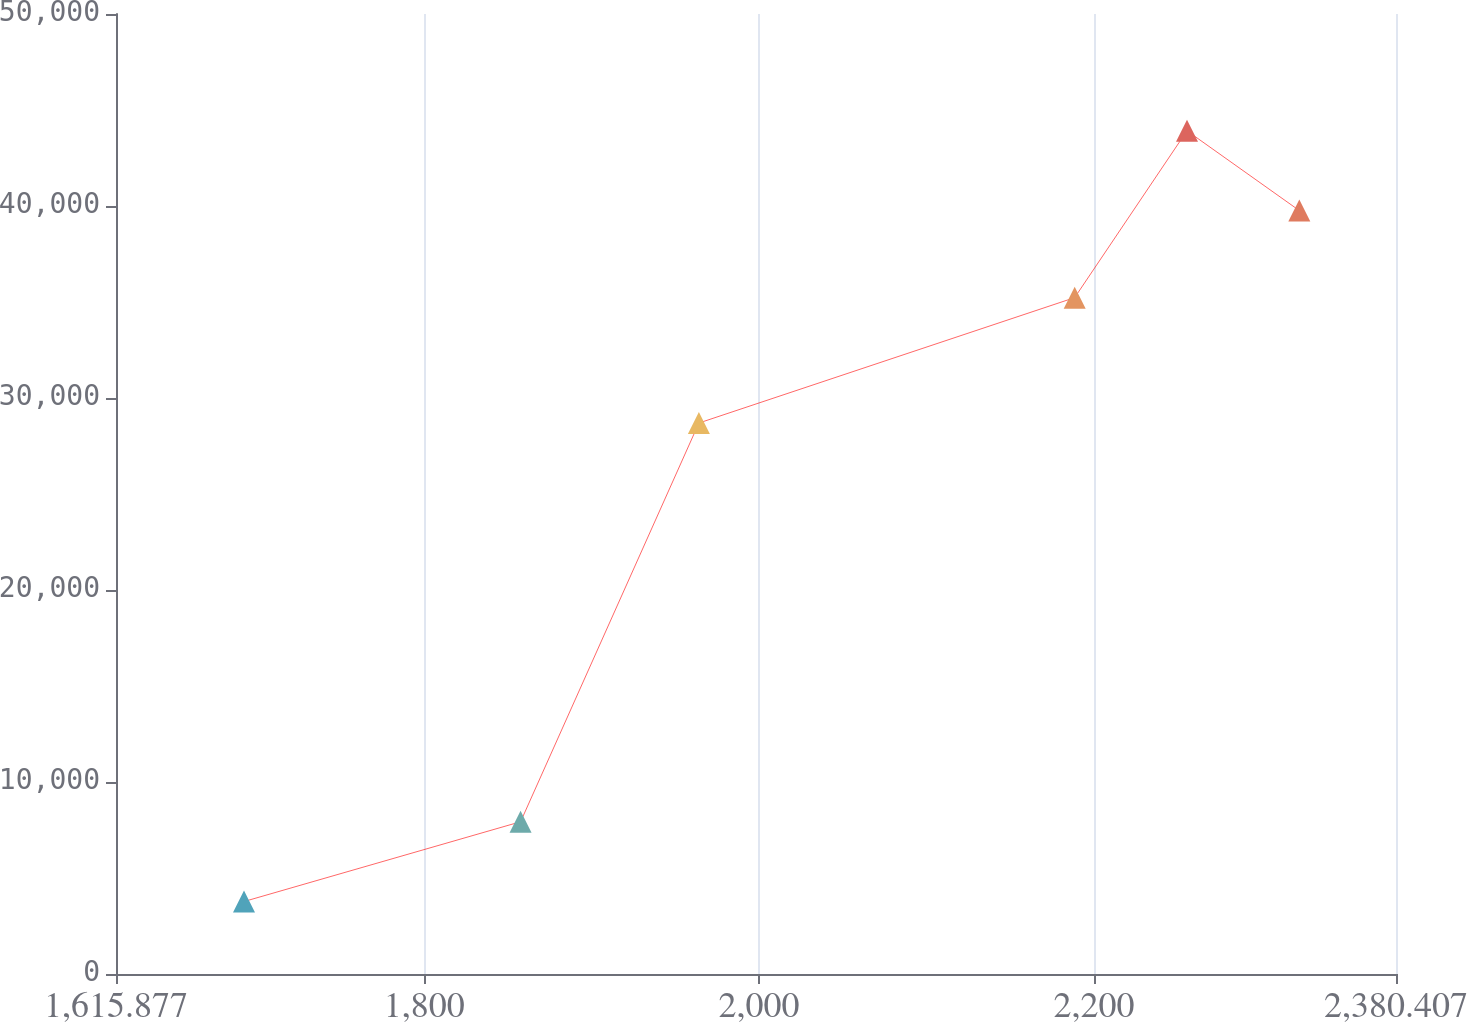<chart> <loc_0><loc_0><loc_500><loc_500><line_chart><ecel><fcel>Unnamed: 1<nl><fcel>1692.33<fcel>3774.91<nl><fcel>1857.53<fcel>7929.51<nl><fcel>1964.04<fcel>28696.8<nl><fcel>2188.48<fcel>35227.7<nl><fcel>2255.57<fcel>43916.9<nl><fcel>2322.66<fcel>39762.3<nl><fcel>2389.76<fcel>48071.5<nl><fcel>2456.86<fcel>12084.1<nl></chart> 